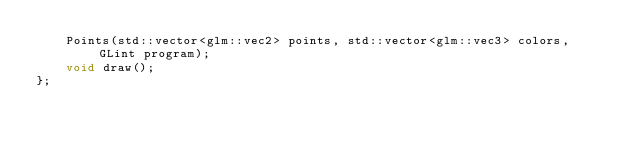Convert code to text. <code><loc_0><loc_0><loc_500><loc_500><_C_>		Points(std::vector<glm::vec2> points, std::vector<glm::vec3> colors, GLint program);
		void draw();
};
</code> 